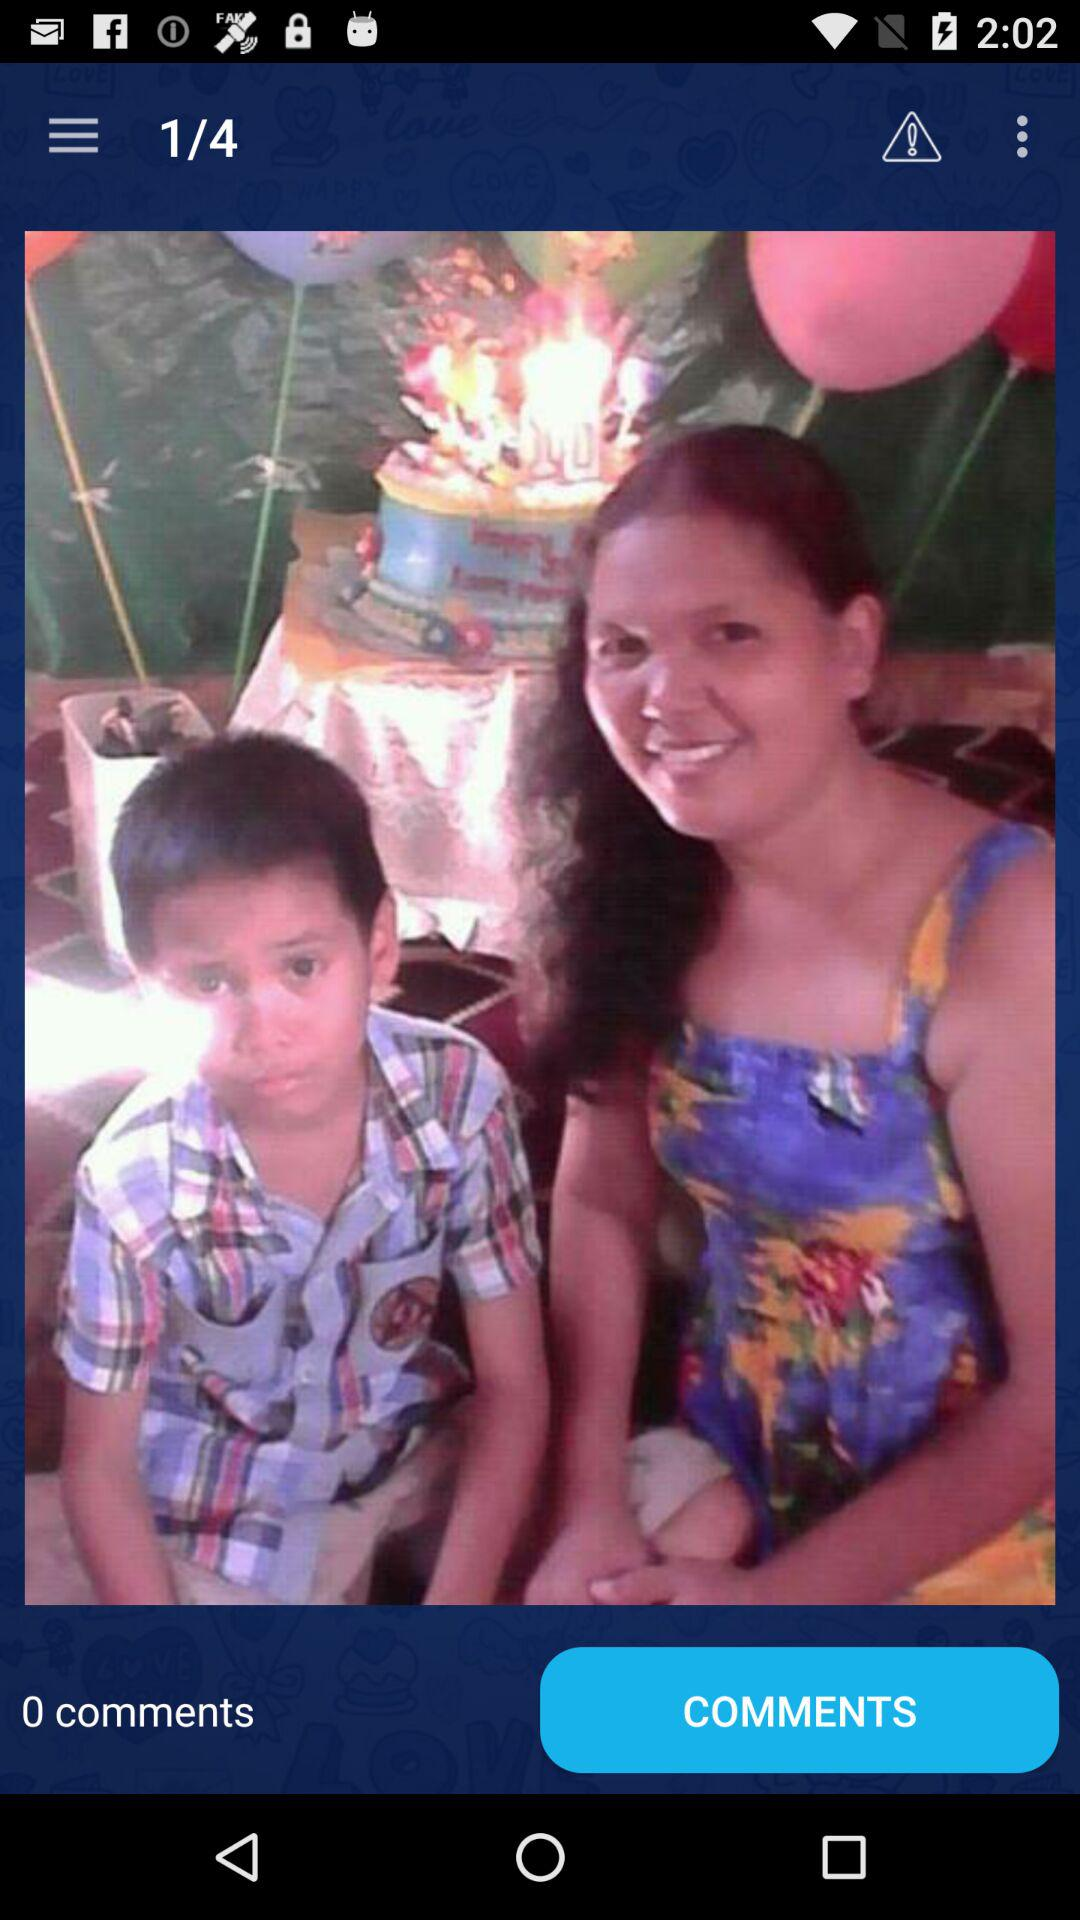What is the count of comments? The count of comments is 0. 